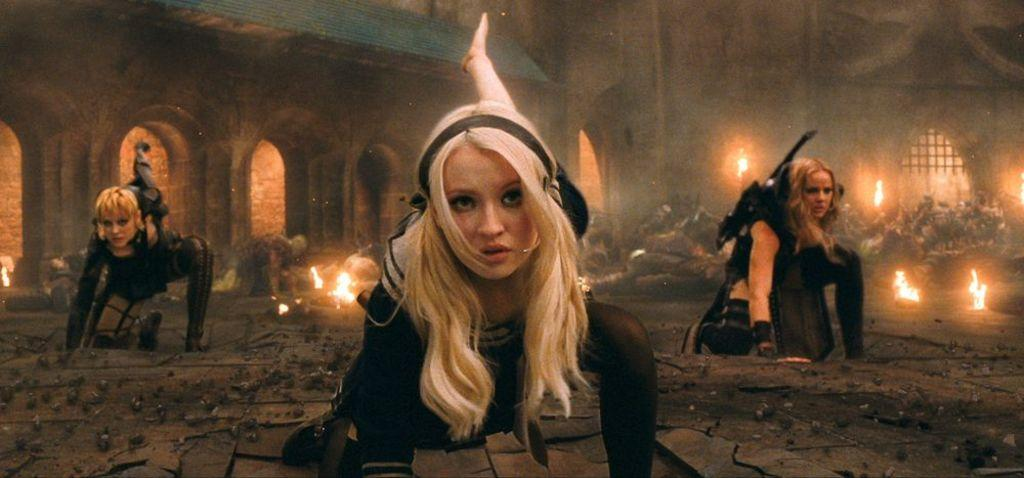What are the three women in the image doing? The three women are kneeling on the ground in the image. How many people are on the ground in the image? There are many people on the ground in the image. What can be seen in the image besides the people on the ground? There is fire visible in the image. What is visible in the background of the image? There are buildings in the background of the image. What type of lift can be seen in the image? There is no lift present in the image. What type of songs are the people singing in the image? There is no indication that the people in the image are singing songs. 